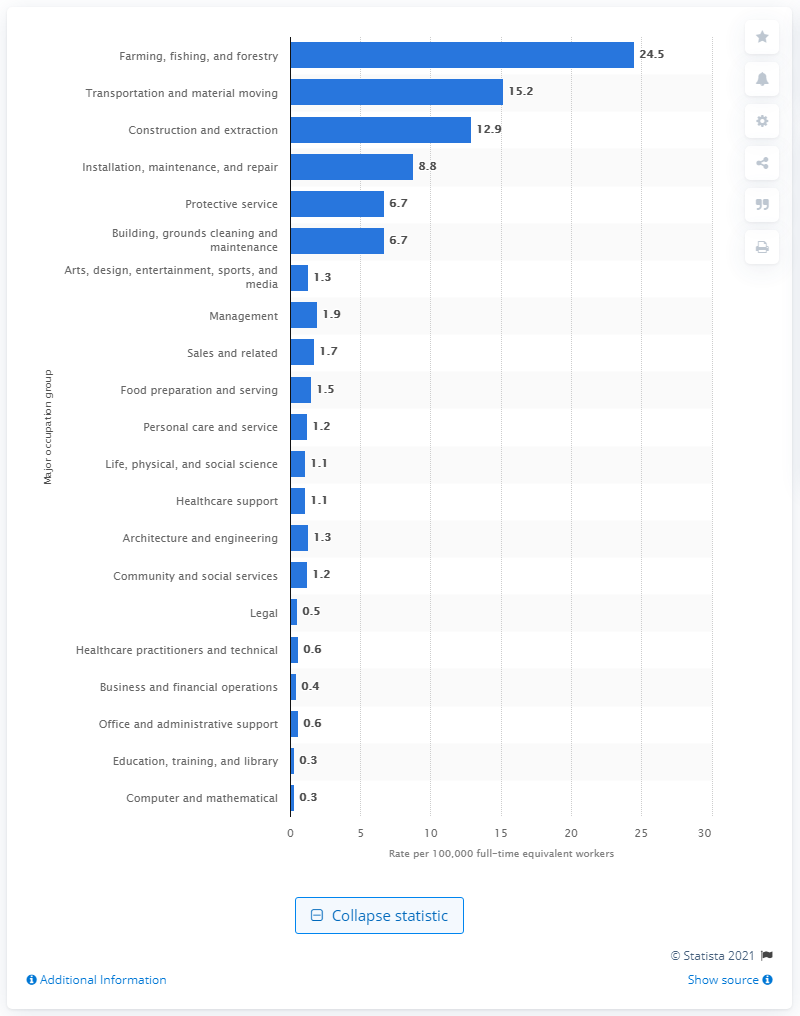Point out several critical features in this image. The highest rate of occupational injury deaths per 100,000 workers was observed in farming, fishing, and forestry occupations, at 24.5 deaths. 